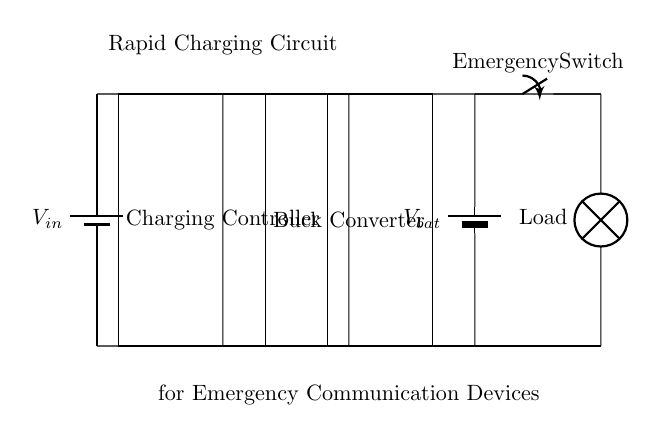What type of circuit is shown? This is a rapid charging circuit, designed specifically for charging emergency communication devices. The diagram reveals that it features essential components that facilitate quick energy transfer.
Answer: rapid charging circuit What are the components of this circuit? The circuit consists of a power source (battery), a charging controller, a buck converter, a battery for storage, a load (lamp), and an emergency switch. Each component's function is indicated by its position and label in the diagram.
Answer: battery, charging controller, buck converter, battery, lamp, emergency switch What is the role of the charging controller? The charging controller regulates the voltage and current flowing to the battery, ensuring that it charges safely and efficiently. It prevents overcharging and maintains optimal operating conditions for the circuit.
Answer: regulate voltage How is the emergency switch connected in the circuit? The emergency switch is connected in series with the load, allowing users to easily turn the load on or off during emergencies. The diagram shows the switch directly between the battery and the load, indicating its position in the circuit path.
Answer: in series with the load What type of converter is used in this circuit? This circuit employs a buck converter, which steps down the voltage from the charging controller to an appropriate level for the battery. The placement and label in the diagram confirm its specific function in energy conversion.
Answer: buck converter What is the purpose of using a buck converter in this circuit? The buck converter serves to reduce the input voltage from the charging controller to a lower voltage suitable for charging the battery efficiently. By stepping down the voltage, it optimizes the charging process and protects the devices from voltage spikes.
Answer: step down voltage How does this circuit support emergency communication devices? This circuit is tailored to provide rapid charging capabilities that ensure emergency communication devices have sufficient power during a disaster scenario. The efficient energy management is crucial for maintaining communication in critical situations.
Answer: rapid charging capability 